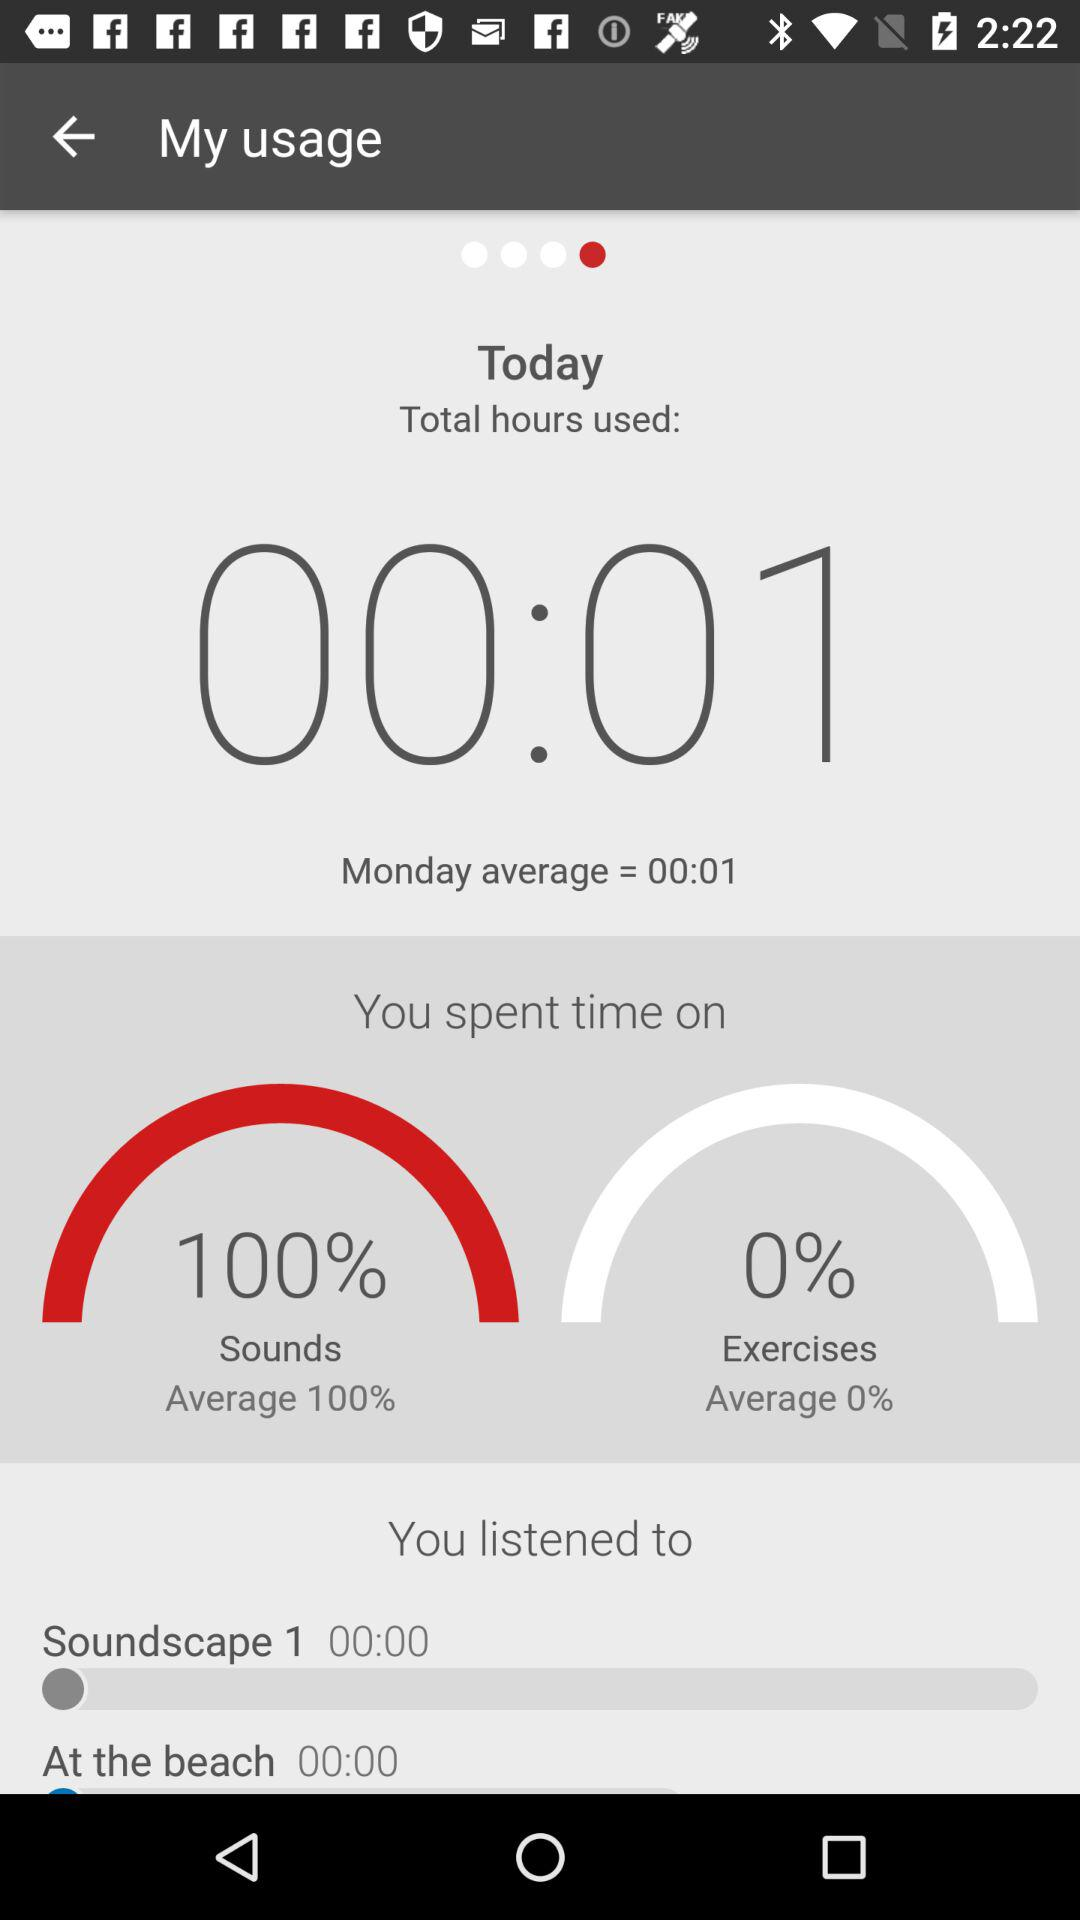What's the exercise average? The exercise average is 0%. 